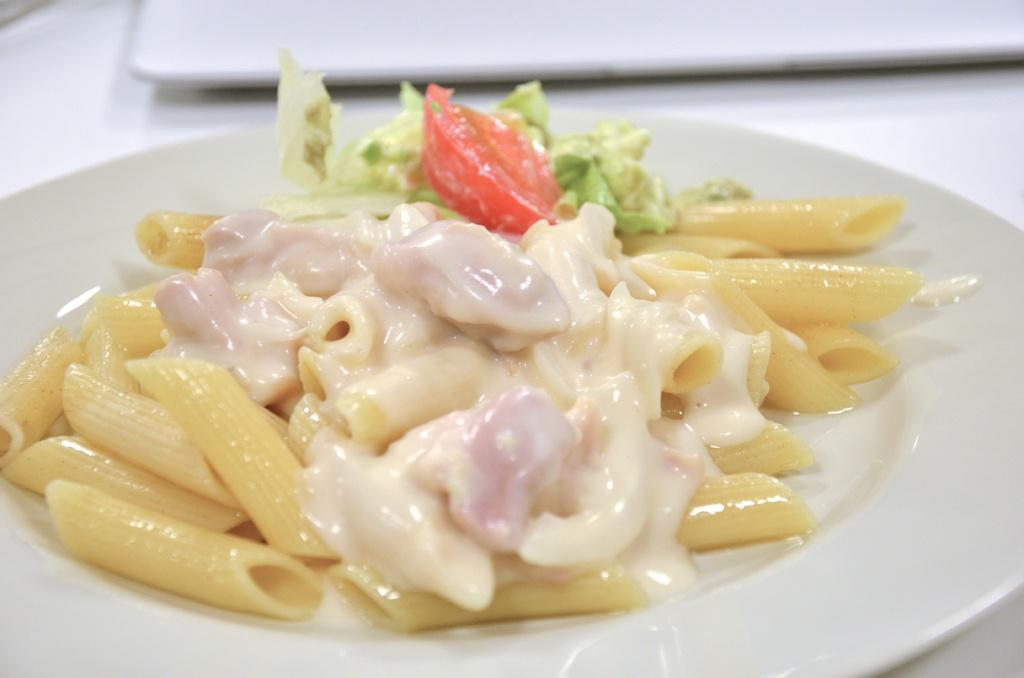What is on the plate in the image? There is food in the plate. Can you describe the colors of the food on the plate? The food has cream, brown, green, and red colors. What color is the plate itself? The plate is white. How does the food on the plate turn into powder? The food on the plate does not turn into powder in the image; it remains as food. 